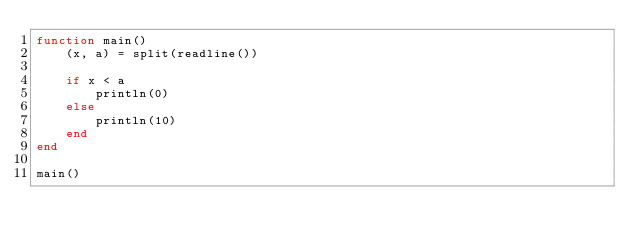Convert code to text. <code><loc_0><loc_0><loc_500><loc_500><_Julia_>function main()
    (x, a) = split(readline())

    if x < a
        println(0)
    else
        println(10)
    end
end

main()</code> 